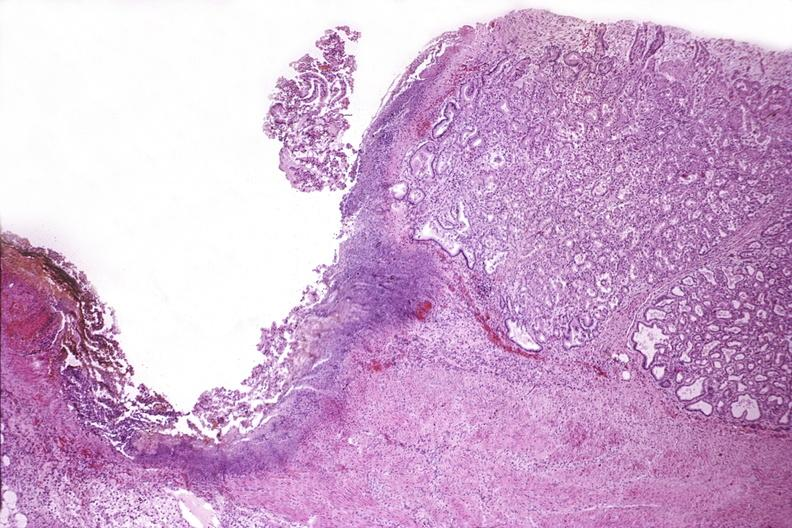does another fiber other frame show duodenum, chronic pepetic ulcer?
Answer the question using a single word or phrase. No 